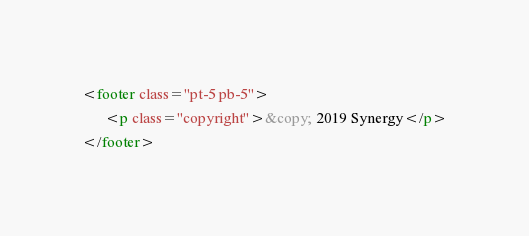<code> <loc_0><loc_0><loc_500><loc_500><_HTML_><footer class="pt-5 pb-5">
      <p class="copyright">&copy; 2019 Synergy</p>
</footer>
</code> 